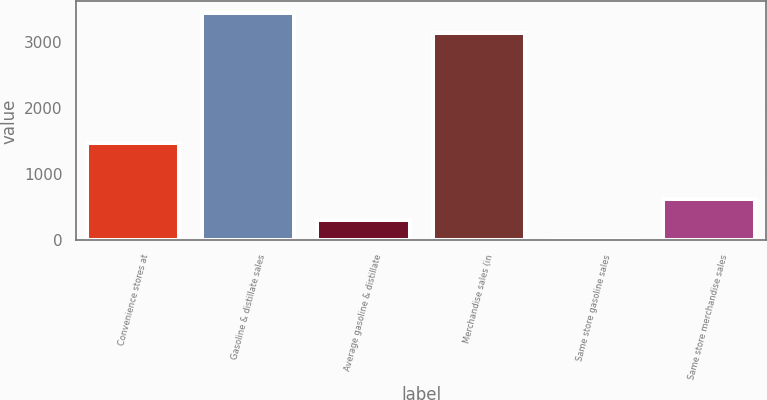Convert chart to OTSL. <chart><loc_0><loc_0><loc_500><loc_500><bar_chart><fcel>Convenience stores at<fcel>Gasoline & distillate sales<fcel>Average gasoline & distillate<fcel>Merchandise sales (in<fcel>Same store gasoline sales<fcel>Same store merchandise sales<nl><fcel>1478<fcel>3449.55<fcel>315.05<fcel>3135<fcel>0.5<fcel>629.6<nl></chart> 